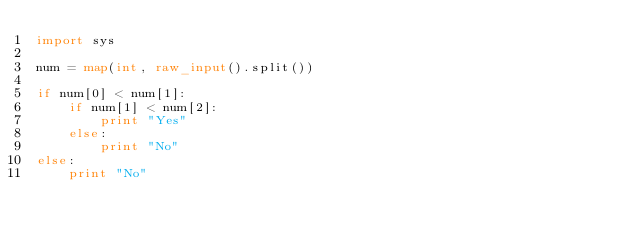Convert code to text. <code><loc_0><loc_0><loc_500><loc_500><_Python_>import sys

num = map(int, raw_input().split())

if num[0] < num[1]:
    if num[1] < num[2]:
        print "Yes"
    else:
        print "No"
else:
    print "No"</code> 